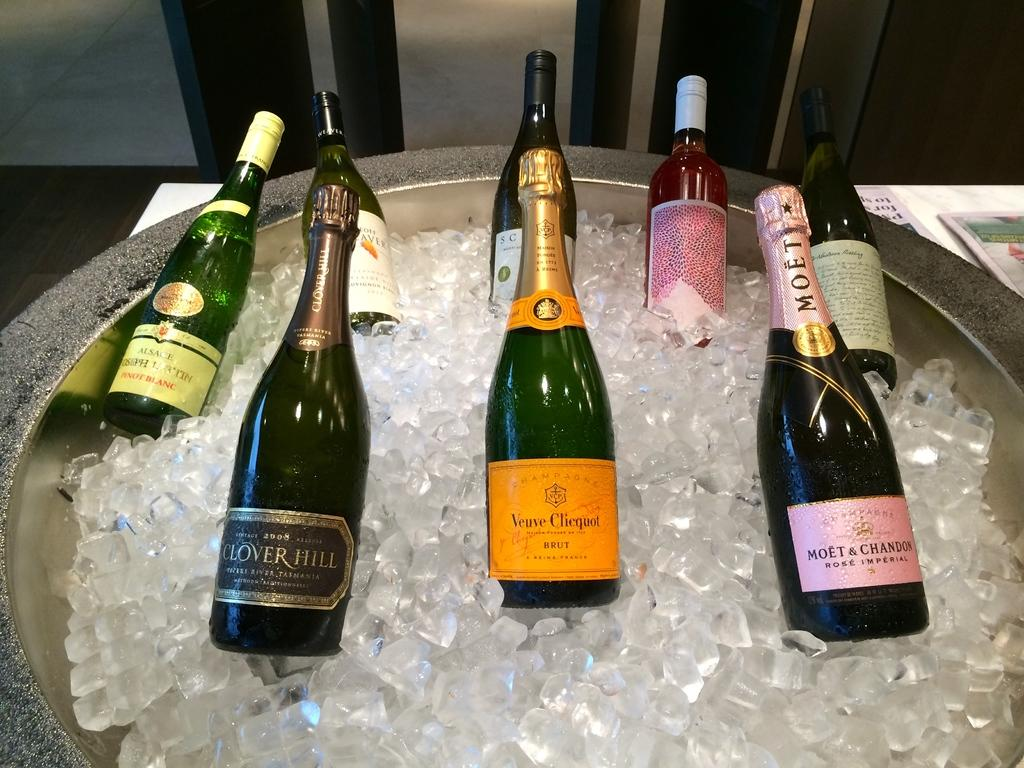Provide a one-sentence caption for the provided image. Eight bottles of champagne sitting in a tube of Ice, and one of them is made by Moet. 